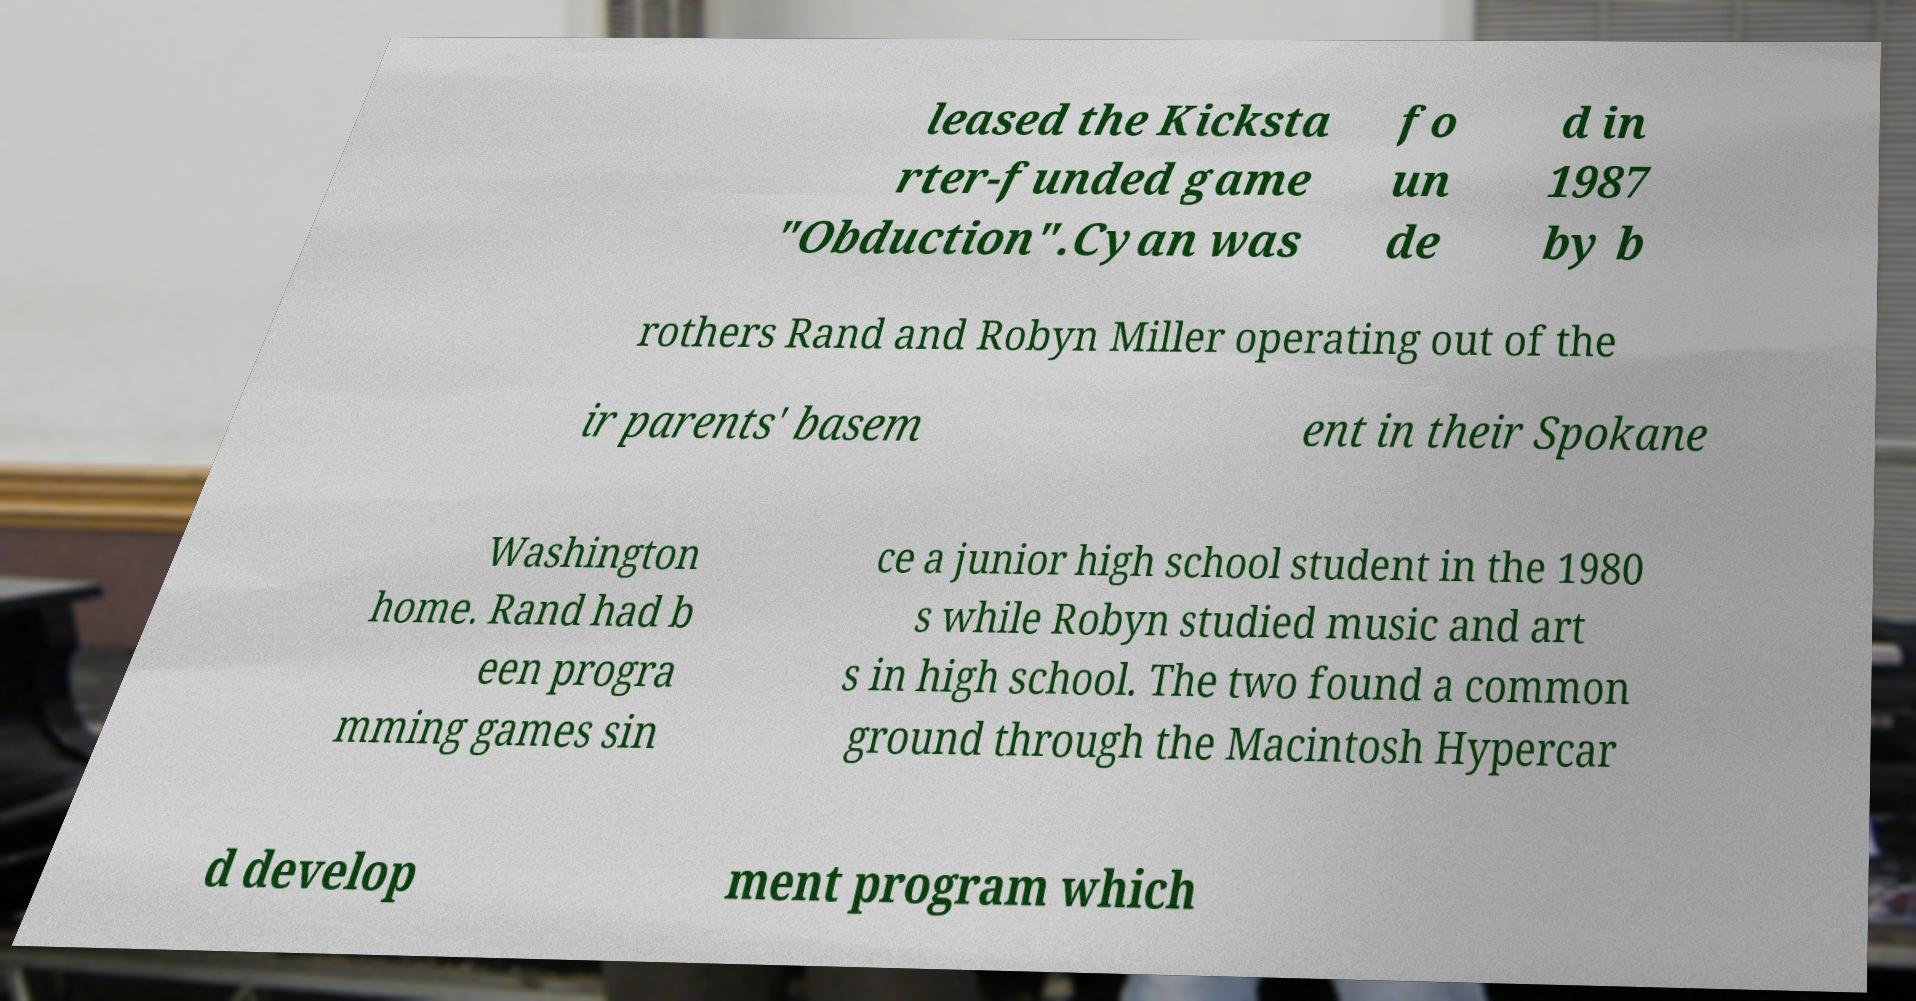Please identify and transcribe the text found in this image. leased the Kicksta rter-funded game "Obduction".Cyan was fo un de d in 1987 by b rothers Rand and Robyn Miller operating out of the ir parents' basem ent in their Spokane Washington home. Rand had b een progra mming games sin ce a junior high school student in the 1980 s while Robyn studied music and art s in high school. The two found a common ground through the Macintosh Hypercar d develop ment program which 